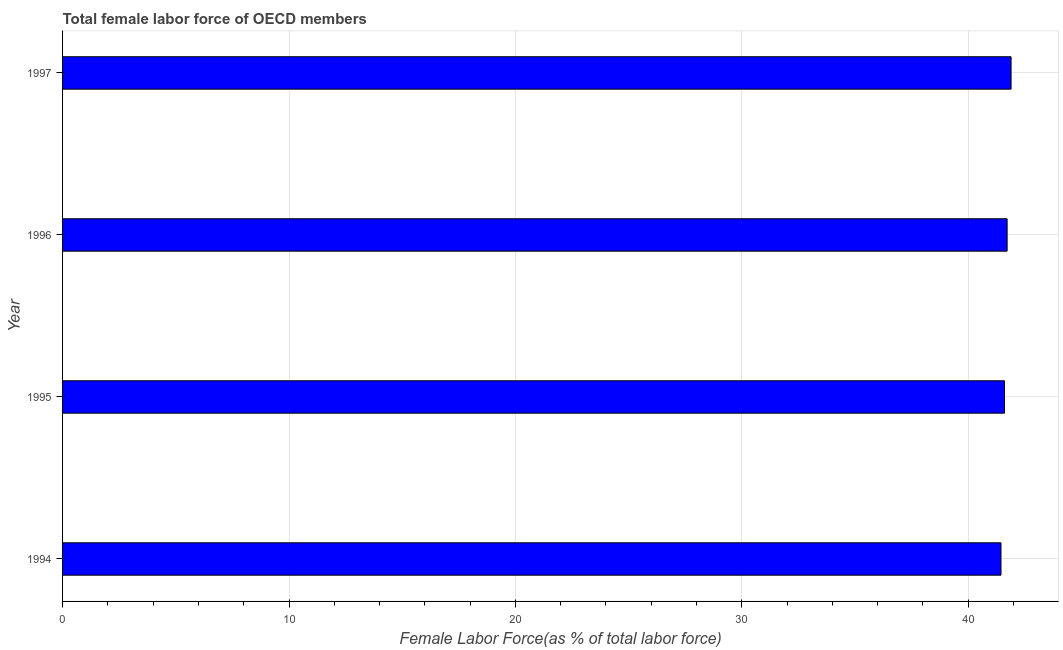Does the graph contain any zero values?
Provide a short and direct response. No. What is the title of the graph?
Offer a very short reply. Total female labor force of OECD members. What is the label or title of the X-axis?
Offer a terse response. Female Labor Force(as % of total labor force). What is the label or title of the Y-axis?
Your answer should be compact. Year. What is the total female labor force in 1995?
Make the answer very short. 41.6. Across all years, what is the maximum total female labor force?
Make the answer very short. 41.89. Across all years, what is the minimum total female labor force?
Offer a terse response. 41.44. In which year was the total female labor force maximum?
Your answer should be compact. 1997. In which year was the total female labor force minimum?
Provide a succinct answer. 1994. What is the sum of the total female labor force?
Ensure brevity in your answer.  166.65. What is the difference between the total female labor force in 1994 and 1997?
Offer a very short reply. -0.45. What is the average total female labor force per year?
Your answer should be very brief. 41.66. What is the median total female labor force?
Provide a succinct answer. 41.66. In how many years, is the total female labor force greater than 6 %?
Provide a succinct answer. 4. Do a majority of the years between 1995 and 1994 (inclusive) have total female labor force greater than 16 %?
Your response must be concise. No. What is the ratio of the total female labor force in 1994 to that in 1997?
Provide a short and direct response. 0.99. What is the difference between the highest and the second highest total female labor force?
Ensure brevity in your answer.  0.17. Is the sum of the total female labor force in 1994 and 1995 greater than the maximum total female labor force across all years?
Offer a terse response. Yes. What is the difference between the highest and the lowest total female labor force?
Your answer should be very brief. 0.45. In how many years, is the total female labor force greater than the average total female labor force taken over all years?
Offer a terse response. 2. What is the Female Labor Force(as % of total labor force) of 1994?
Your answer should be compact. 41.44. What is the Female Labor Force(as % of total labor force) in 1995?
Ensure brevity in your answer.  41.6. What is the Female Labor Force(as % of total labor force) of 1996?
Your answer should be compact. 41.72. What is the Female Labor Force(as % of total labor force) in 1997?
Your answer should be very brief. 41.89. What is the difference between the Female Labor Force(as % of total labor force) in 1994 and 1995?
Offer a terse response. -0.16. What is the difference between the Female Labor Force(as % of total labor force) in 1994 and 1996?
Provide a short and direct response. -0.27. What is the difference between the Female Labor Force(as % of total labor force) in 1994 and 1997?
Offer a very short reply. -0.45. What is the difference between the Female Labor Force(as % of total labor force) in 1995 and 1996?
Make the answer very short. -0.12. What is the difference between the Female Labor Force(as % of total labor force) in 1995 and 1997?
Your answer should be very brief. -0.29. What is the difference between the Female Labor Force(as % of total labor force) in 1996 and 1997?
Keep it short and to the point. -0.17. What is the ratio of the Female Labor Force(as % of total labor force) in 1994 to that in 1995?
Offer a very short reply. 1. What is the ratio of the Female Labor Force(as % of total labor force) in 1994 to that in 1996?
Keep it short and to the point. 0.99. 